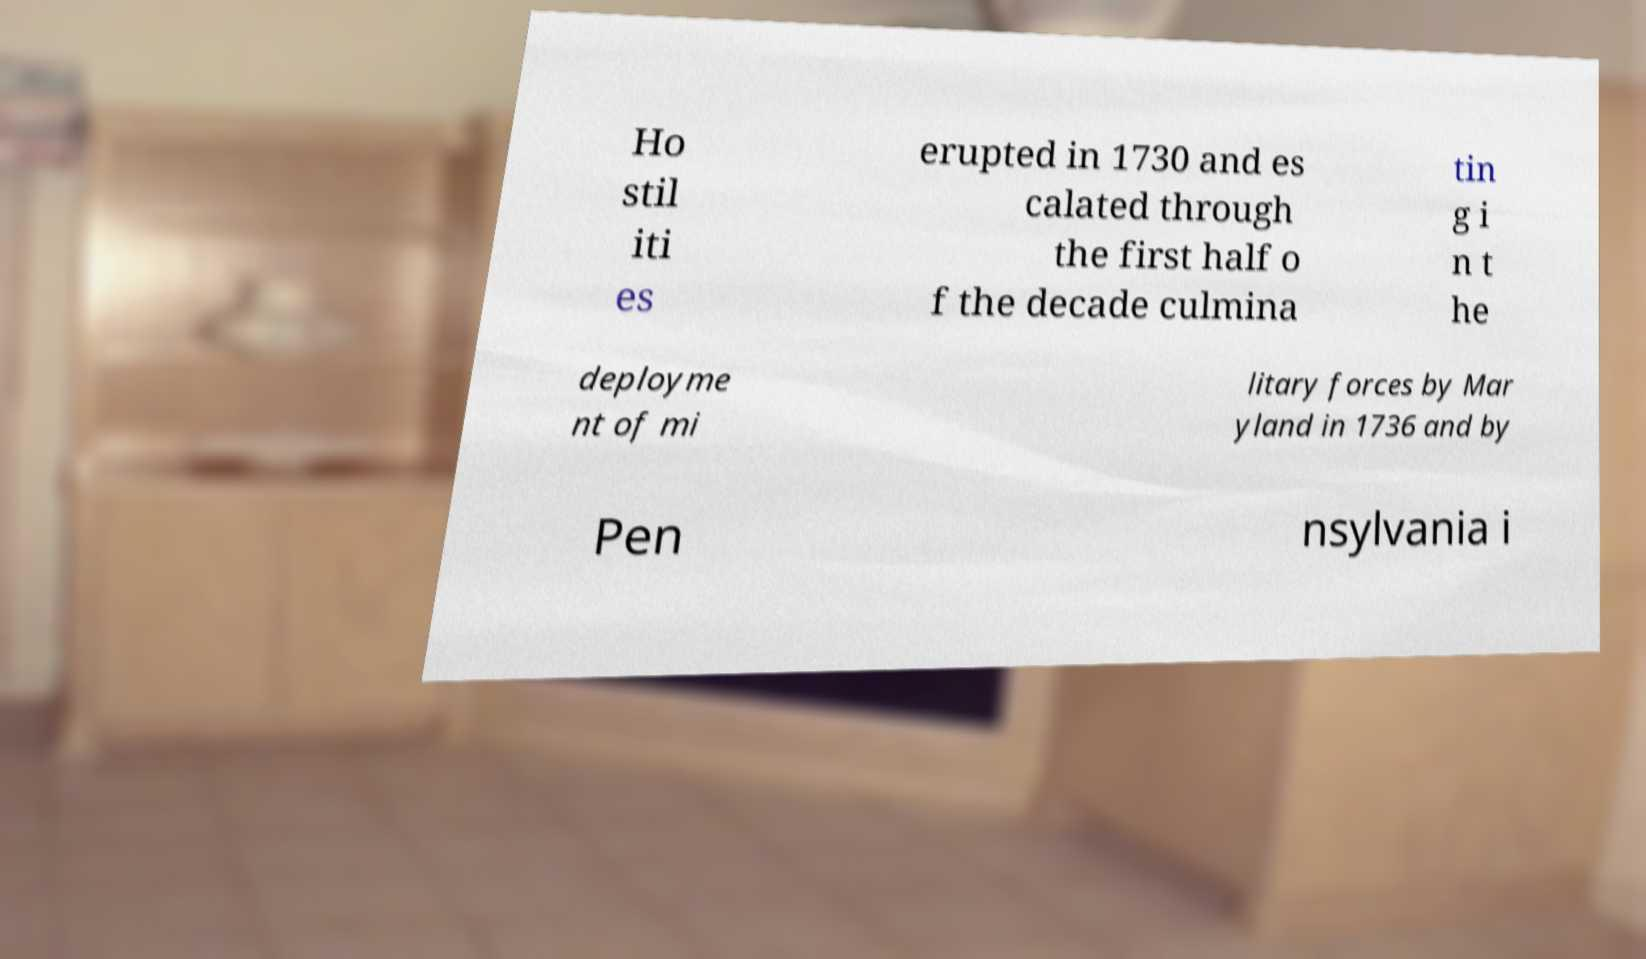For documentation purposes, I need the text within this image transcribed. Could you provide that? Ho stil iti es erupted in 1730 and es calated through the first half o f the decade culmina tin g i n t he deployme nt of mi litary forces by Mar yland in 1736 and by Pen nsylvania i 